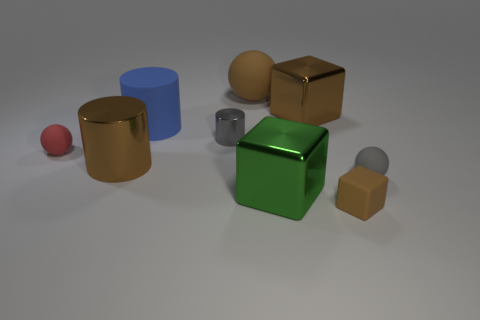Add 1 small gray metallic cylinders. How many objects exist? 10 Subtract all spheres. How many objects are left? 6 Subtract all brown matte cylinders. Subtract all gray shiny cylinders. How many objects are left? 8 Add 7 cylinders. How many cylinders are left? 10 Add 6 tiny cylinders. How many tiny cylinders exist? 7 Subtract 0 blue balls. How many objects are left? 9 